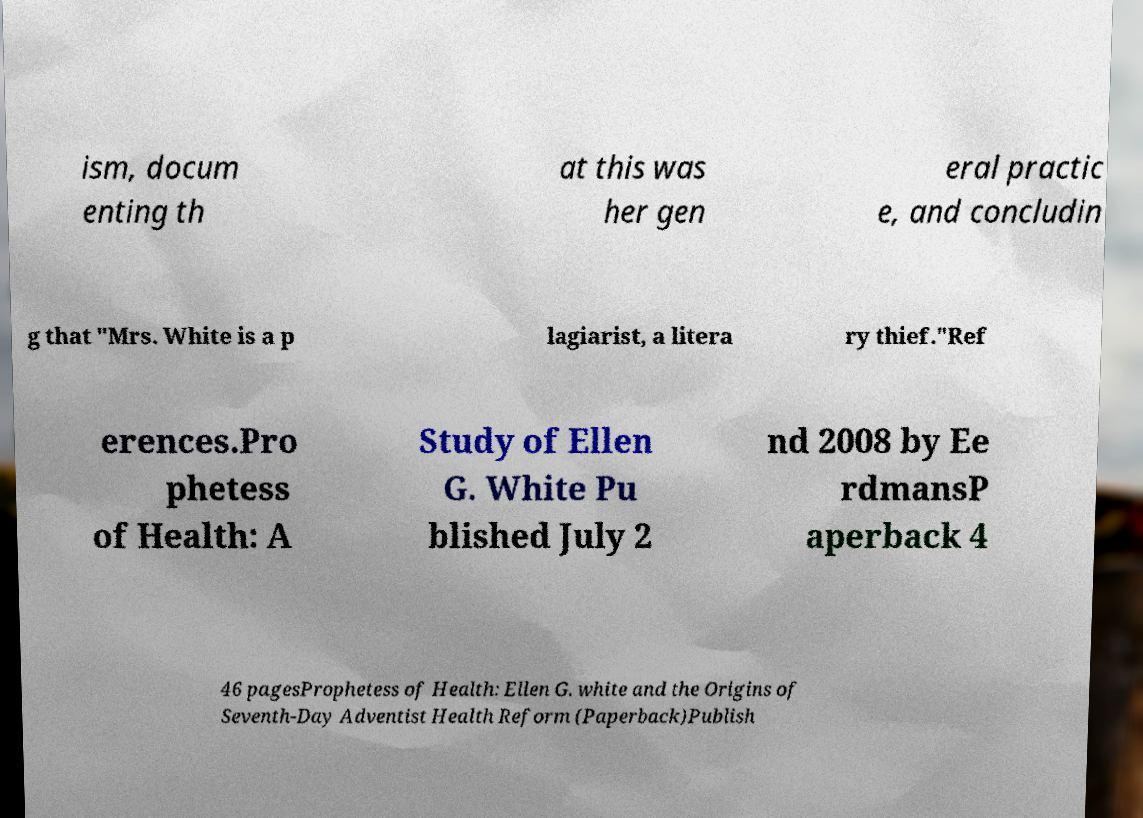Please identify and transcribe the text found in this image. ism, docum enting th at this was her gen eral practic e, and concludin g that "Mrs. White is a p lagiarist, a litera ry thief."Ref erences.Pro phetess of Health: A Study of Ellen G. White Pu blished July 2 nd 2008 by Ee rdmansP aperback 4 46 pagesProphetess of Health: Ellen G. white and the Origins of Seventh-Day Adventist Health Reform (Paperback)Publish 